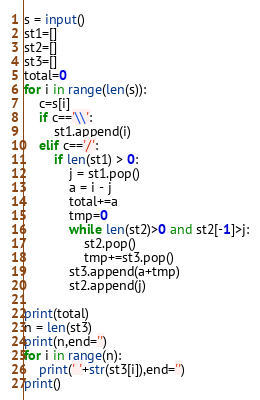<code> <loc_0><loc_0><loc_500><loc_500><_Python_>s = input()
st1=[]
st2=[]
st3=[]
total=0
for i in range(len(s)):
	c=s[i]
	if c=='\\':
		st1.append(i)
	elif c=='/':
		if len(st1) > 0:
			j = st1.pop()
			a = i - j
			total+=a
			tmp=0
			while len(st2)>0 and st2[-1]>j:
				st2.pop()
				tmp+=st3.pop()
			st3.append(a+tmp)
			st2.append(j)
			
print(total)
n = len(st3)
print(n,end='')
for i in range(n):
	print(' '+str(st3[i]),end='')
print()

</code> 